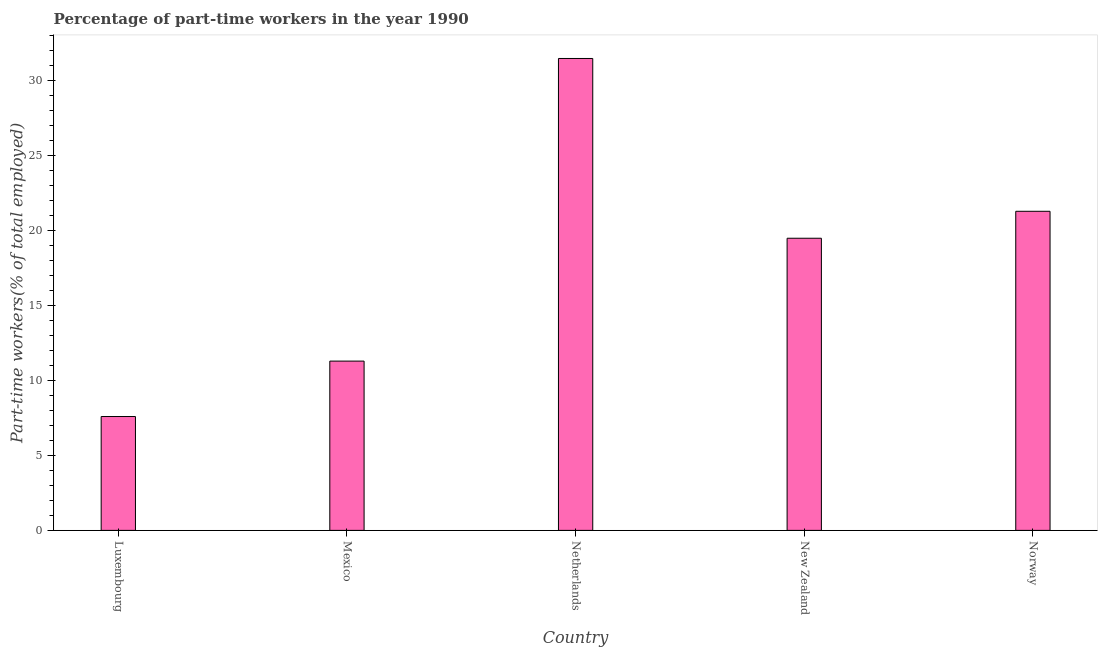Does the graph contain grids?
Your response must be concise. No. What is the title of the graph?
Offer a terse response. Percentage of part-time workers in the year 1990. What is the label or title of the Y-axis?
Your answer should be compact. Part-time workers(% of total employed). What is the percentage of part-time workers in Mexico?
Your response must be concise. 11.3. Across all countries, what is the maximum percentage of part-time workers?
Offer a terse response. 31.5. Across all countries, what is the minimum percentage of part-time workers?
Offer a terse response. 7.6. In which country was the percentage of part-time workers maximum?
Keep it short and to the point. Netherlands. In which country was the percentage of part-time workers minimum?
Give a very brief answer. Luxembourg. What is the sum of the percentage of part-time workers?
Make the answer very short. 91.2. What is the difference between the percentage of part-time workers in Mexico and Netherlands?
Keep it short and to the point. -20.2. What is the average percentage of part-time workers per country?
Make the answer very short. 18.24. What is the median percentage of part-time workers?
Keep it short and to the point. 19.5. What is the ratio of the percentage of part-time workers in Mexico to that in New Zealand?
Your answer should be very brief. 0.58. Is the percentage of part-time workers in Luxembourg less than that in New Zealand?
Your answer should be very brief. Yes. Is the difference between the percentage of part-time workers in Netherlands and New Zealand greater than the difference between any two countries?
Keep it short and to the point. No. What is the difference between the highest and the second highest percentage of part-time workers?
Your answer should be compact. 10.2. What is the difference between the highest and the lowest percentage of part-time workers?
Offer a very short reply. 23.9. How many countries are there in the graph?
Make the answer very short. 5. What is the difference between two consecutive major ticks on the Y-axis?
Ensure brevity in your answer.  5. Are the values on the major ticks of Y-axis written in scientific E-notation?
Keep it short and to the point. No. What is the Part-time workers(% of total employed) in Luxembourg?
Your response must be concise. 7.6. What is the Part-time workers(% of total employed) in Mexico?
Your answer should be compact. 11.3. What is the Part-time workers(% of total employed) of Netherlands?
Provide a short and direct response. 31.5. What is the Part-time workers(% of total employed) of New Zealand?
Your answer should be compact. 19.5. What is the Part-time workers(% of total employed) of Norway?
Your answer should be very brief. 21.3. What is the difference between the Part-time workers(% of total employed) in Luxembourg and Netherlands?
Keep it short and to the point. -23.9. What is the difference between the Part-time workers(% of total employed) in Luxembourg and New Zealand?
Your answer should be very brief. -11.9. What is the difference between the Part-time workers(% of total employed) in Luxembourg and Norway?
Offer a very short reply. -13.7. What is the difference between the Part-time workers(% of total employed) in Mexico and Netherlands?
Provide a short and direct response. -20.2. What is the difference between the Part-time workers(% of total employed) in Mexico and New Zealand?
Offer a very short reply. -8.2. What is the difference between the Part-time workers(% of total employed) in Netherlands and New Zealand?
Offer a terse response. 12. What is the difference between the Part-time workers(% of total employed) in New Zealand and Norway?
Offer a terse response. -1.8. What is the ratio of the Part-time workers(% of total employed) in Luxembourg to that in Mexico?
Your response must be concise. 0.67. What is the ratio of the Part-time workers(% of total employed) in Luxembourg to that in Netherlands?
Offer a terse response. 0.24. What is the ratio of the Part-time workers(% of total employed) in Luxembourg to that in New Zealand?
Keep it short and to the point. 0.39. What is the ratio of the Part-time workers(% of total employed) in Luxembourg to that in Norway?
Ensure brevity in your answer.  0.36. What is the ratio of the Part-time workers(% of total employed) in Mexico to that in Netherlands?
Your response must be concise. 0.36. What is the ratio of the Part-time workers(% of total employed) in Mexico to that in New Zealand?
Provide a succinct answer. 0.58. What is the ratio of the Part-time workers(% of total employed) in Mexico to that in Norway?
Provide a short and direct response. 0.53. What is the ratio of the Part-time workers(% of total employed) in Netherlands to that in New Zealand?
Give a very brief answer. 1.61. What is the ratio of the Part-time workers(% of total employed) in Netherlands to that in Norway?
Offer a very short reply. 1.48. What is the ratio of the Part-time workers(% of total employed) in New Zealand to that in Norway?
Offer a terse response. 0.92. 